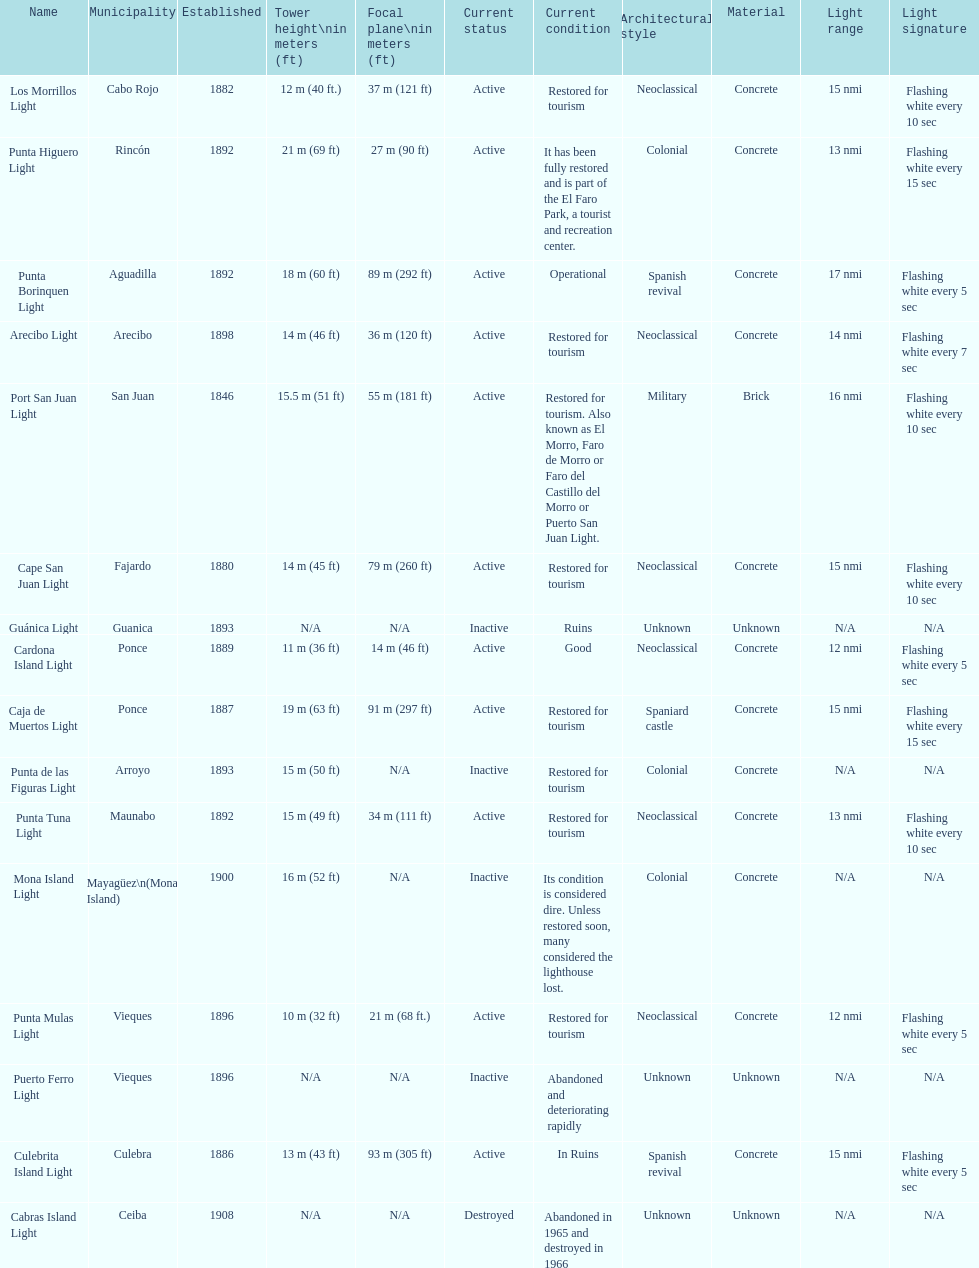Were any towers established before the year 1800? No. 